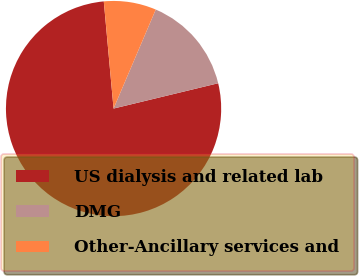Convert chart to OTSL. <chart><loc_0><loc_0><loc_500><loc_500><pie_chart><fcel>US dialysis and related lab<fcel>DMG<fcel>Other-Ancillary services and<nl><fcel>77.33%<fcel>14.81%<fcel>7.86%<nl></chart> 